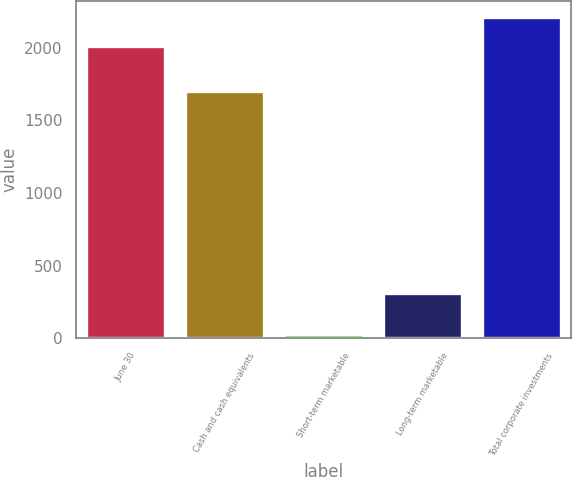Convert chart to OTSL. <chart><loc_0><loc_0><loc_500><loc_500><bar_chart><fcel>June 30<fcel>Cash and cash equivalents<fcel>Short-term marketable<fcel>Long-term marketable<fcel>Total corporate investments<nl><fcel>2013<fcel>1699.1<fcel>28<fcel>314<fcel>2214.31<nl></chart> 